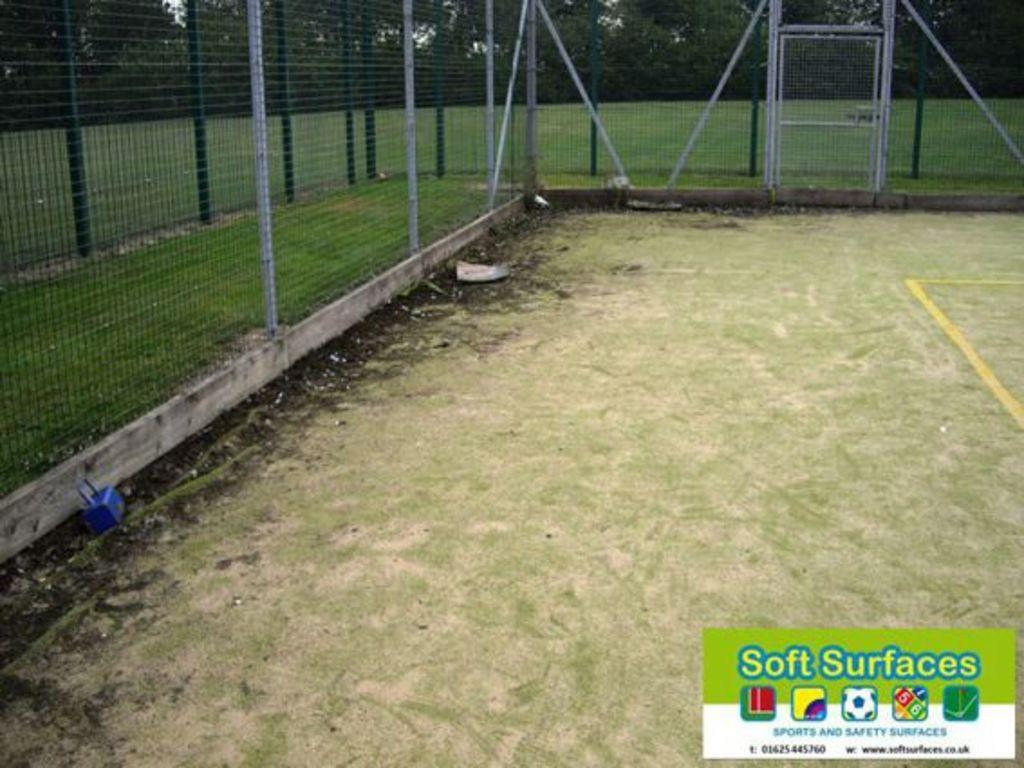What type of surface is visible in the image? There is a ground in the image. What covers the ground in the image? The ground has grass on it. What can be seen on both sides of the ground? There is fencing on both sides of the ground. What can be seen in the distance in the image? There are trees visible in the background of the image. What type of dinner is being served on the ground in the image? There is no dinner or food visible in the image; it only shows a ground with grass and fencing. 